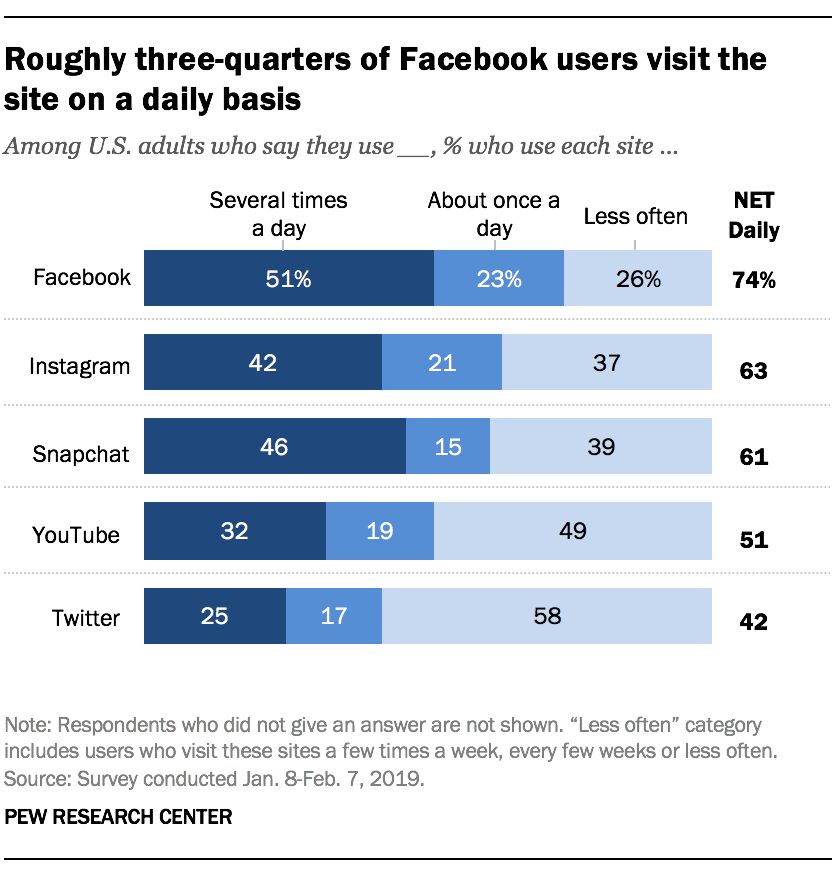Outline some significant characteristics in this image. The sum of the largest navy blue bar and the medians of all the bars in the Twitter category is 84.5. There are three shades of blue used to represent the graph. 